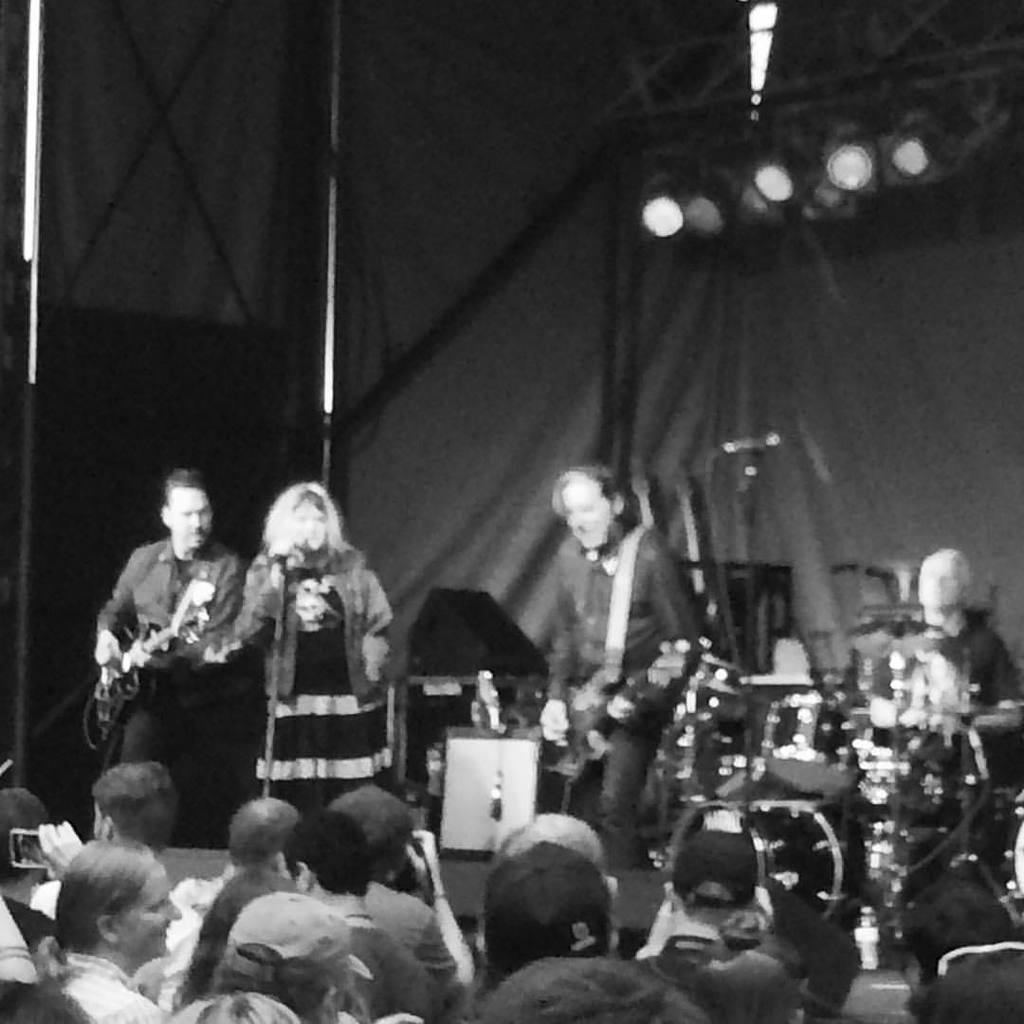Could you give a brief overview of what you see in this image? In the image there are four people three men and one woman. Who is holding her microphone from left to right three men's are playing their musical instruments and there are group of people as audience. In background there are curtains,lights. 